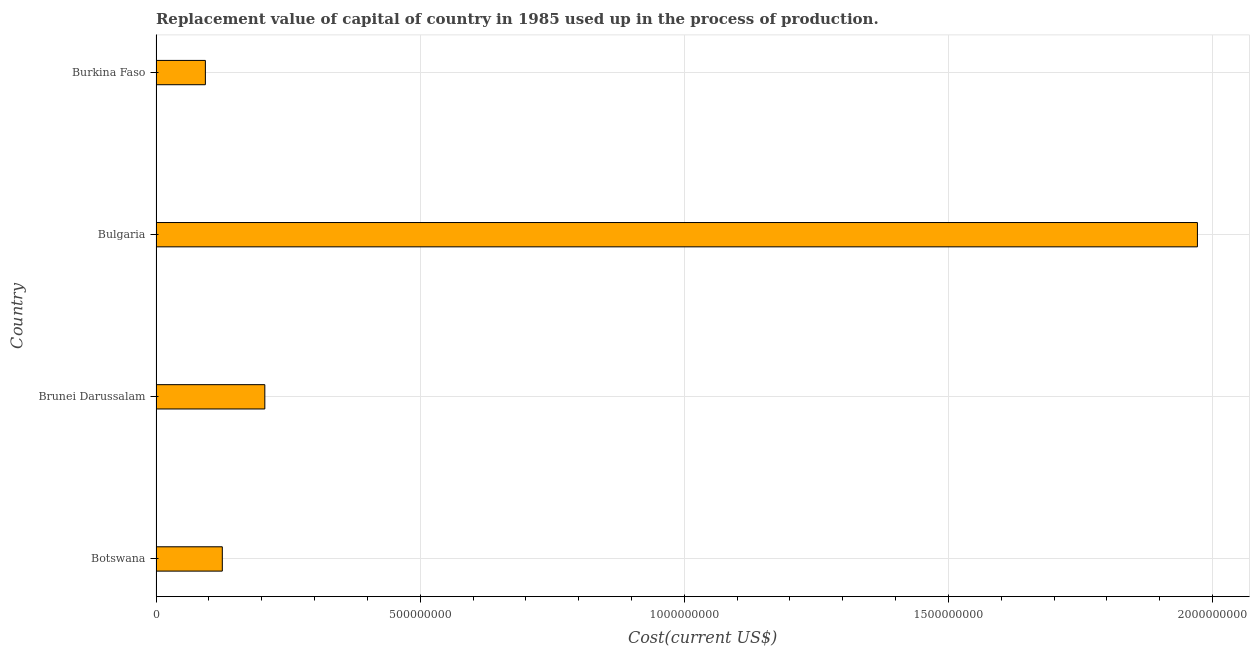Does the graph contain grids?
Provide a short and direct response. Yes. What is the title of the graph?
Your response must be concise. Replacement value of capital of country in 1985 used up in the process of production. What is the label or title of the X-axis?
Your response must be concise. Cost(current US$). What is the consumption of fixed capital in Brunei Darussalam?
Provide a succinct answer. 2.06e+08. Across all countries, what is the maximum consumption of fixed capital?
Make the answer very short. 1.97e+09. Across all countries, what is the minimum consumption of fixed capital?
Make the answer very short. 9.34e+07. In which country was the consumption of fixed capital minimum?
Ensure brevity in your answer.  Burkina Faso. What is the sum of the consumption of fixed capital?
Give a very brief answer. 2.40e+09. What is the difference between the consumption of fixed capital in Botswana and Burkina Faso?
Make the answer very short. 3.21e+07. What is the average consumption of fixed capital per country?
Offer a terse response. 5.99e+08. What is the median consumption of fixed capital?
Ensure brevity in your answer.  1.66e+08. In how many countries, is the consumption of fixed capital greater than 1000000000 US$?
Your answer should be very brief. 1. What is the ratio of the consumption of fixed capital in Botswana to that in Bulgaria?
Your answer should be compact. 0.06. Is the consumption of fixed capital in Botswana less than that in Burkina Faso?
Your answer should be very brief. No. What is the difference between the highest and the second highest consumption of fixed capital?
Keep it short and to the point. 1.77e+09. What is the difference between the highest and the lowest consumption of fixed capital?
Make the answer very short. 1.88e+09. How many countries are there in the graph?
Give a very brief answer. 4. Are the values on the major ticks of X-axis written in scientific E-notation?
Give a very brief answer. No. What is the Cost(current US$) in Botswana?
Your answer should be compact. 1.25e+08. What is the Cost(current US$) of Brunei Darussalam?
Offer a very short reply. 2.06e+08. What is the Cost(current US$) in Bulgaria?
Keep it short and to the point. 1.97e+09. What is the Cost(current US$) in Burkina Faso?
Your answer should be compact. 9.34e+07. What is the difference between the Cost(current US$) in Botswana and Brunei Darussalam?
Your response must be concise. -8.05e+07. What is the difference between the Cost(current US$) in Botswana and Bulgaria?
Offer a very short reply. -1.85e+09. What is the difference between the Cost(current US$) in Botswana and Burkina Faso?
Offer a terse response. 3.21e+07. What is the difference between the Cost(current US$) in Brunei Darussalam and Bulgaria?
Provide a succinct answer. -1.77e+09. What is the difference between the Cost(current US$) in Brunei Darussalam and Burkina Faso?
Provide a succinct answer. 1.13e+08. What is the difference between the Cost(current US$) in Bulgaria and Burkina Faso?
Offer a very short reply. 1.88e+09. What is the ratio of the Cost(current US$) in Botswana to that in Brunei Darussalam?
Provide a succinct answer. 0.61. What is the ratio of the Cost(current US$) in Botswana to that in Bulgaria?
Give a very brief answer. 0.06. What is the ratio of the Cost(current US$) in Botswana to that in Burkina Faso?
Your answer should be very brief. 1.34. What is the ratio of the Cost(current US$) in Brunei Darussalam to that in Bulgaria?
Your answer should be compact. 0.1. What is the ratio of the Cost(current US$) in Brunei Darussalam to that in Burkina Faso?
Offer a terse response. 2.21. What is the ratio of the Cost(current US$) in Bulgaria to that in Burkina Faso?
Offer a terse response. 21.1. 